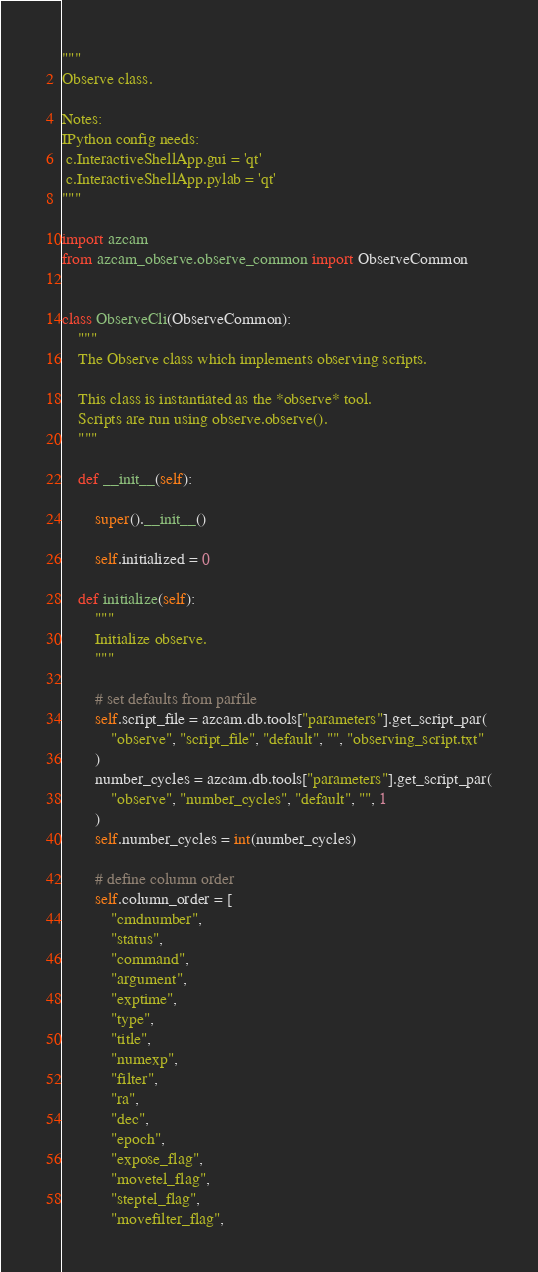Convert code to text. <code><loc_0><loc_0><loc_500><loc_500><_Python_>"""
Observe class.

Notes:
IPython config needs:
 c.InteractiveShellApp.gui = 'qt'
 c.InteractiveShellApp.pylab = 'qt'
"""

import azcam
from azcam_observe.observe_common import ObserveCommon


class ObserveCli(ObserveCommon):
    """
    The Observe class which implements observing scripts.

    This class is instantiated as the *observe* tool.
    Scripts are run using observe.observe().
    """

    def __init__(self):

        super().__init__()

        self.initialized = 0

    def initialize(self):
        """
        Initialize observe.
        """

        # set defaults from parfile
        self.script_file = azcam.db.tools["parameters"].get_script_par(
            "observe", "script_file", "default", "", "observing_script.txt"
        )
        number_cycles = azcam.db.tools["parameters"].get_script_par(
            "observe", "number_cycles", "default", "", 1
        )
        self.number_cycles = int(number_cycles)

        # define column order
        self.column_order = [
            "cmdnumber",
            "status",
            "command",
            "argument",
            "exptime",
            "type",
            "title",
            "numexp",
            "filter",
            "ra",
            "dec",
            "epoch",
            "expose_flag",
            "movetel_flag",
            "steptel_flag",
            "movefilter_flag",</code> 